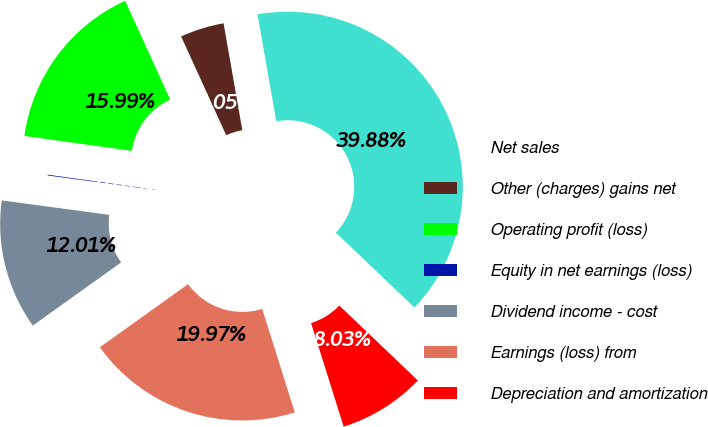Convert chart to OTSL. <chart><loc_0><loc_0><loc_500><loc_500><pie_chart><fcel>Net sales<fcel>Other (charges) gains net<fcel>Operating profit (loss)<fcel>Equity in net earnings (loss)<fcel>Dividend income - cost<fcel>Earnings (loss) from<fcel>Depreciation and amortization<nl><fcel>39.88%<fcel>4.05%<fcel>15.99%<fcel>0.07%<fcel>12.01%<fcel>19.97%<fcel>8.03%<nl></chart> 